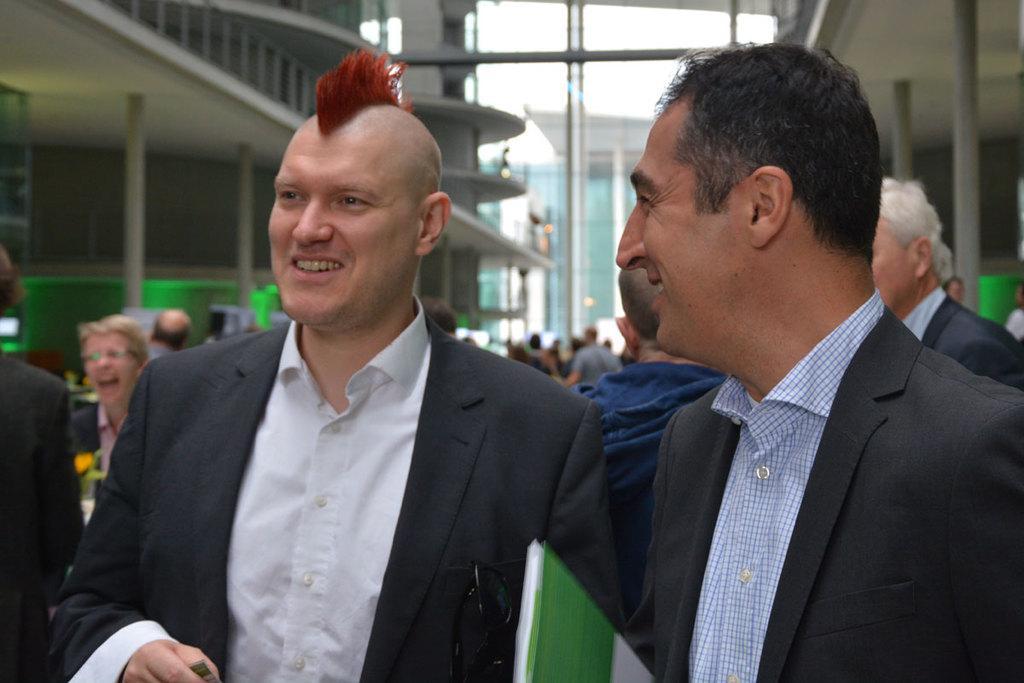Please provide a concise description of this image. This image is taken outdoors. In the middle of the image there are two men with smiling faces. In the background there are many people and there are a few buildings. 